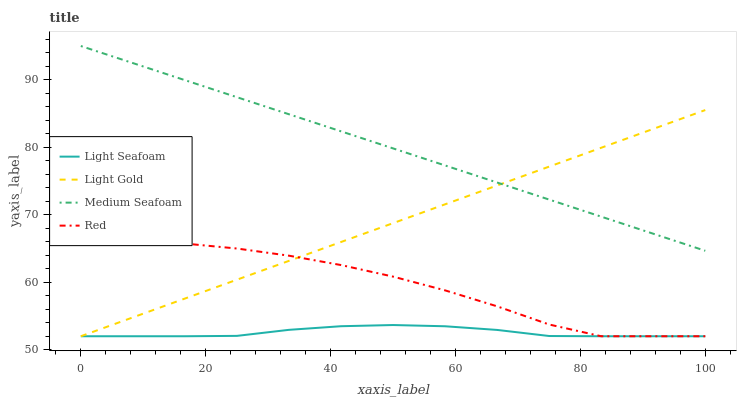Does Light Seafoam have the minimum area under the curve?
Answer yes or no. Yes. Does Medium Seafoam have the maximum area under the curve?
Answer yes or no. Yes. Does Light Gold have the minimum area under the curve?
Answer yes or no. No. Does Light Gold have the maximum area under the curve?
Answer yes or no. No. Is Medium Seafoam the smoothest?
Answer yes or no. Yes. Is Red the roughest?
Answer yes or no. Yes. Is Light Gold the smoothest?
Answer yes or no. No. Is Light Gold the roughest?
Answer yes or no. No. Does Medium Seafoam have the lowest value?
Answer yes or no. No. Does Light Gold have the highest value?
Answer yes or no. No. Is Light Seafoam less than Medium Seafoam?
Answer yes or no. Yes. Is Medium Seafoam greater than Light Seafoam?
Answer yes or no. Yes. Does Light Seafoam intersect Medium Seafoam?
Answer yes or no. No. 